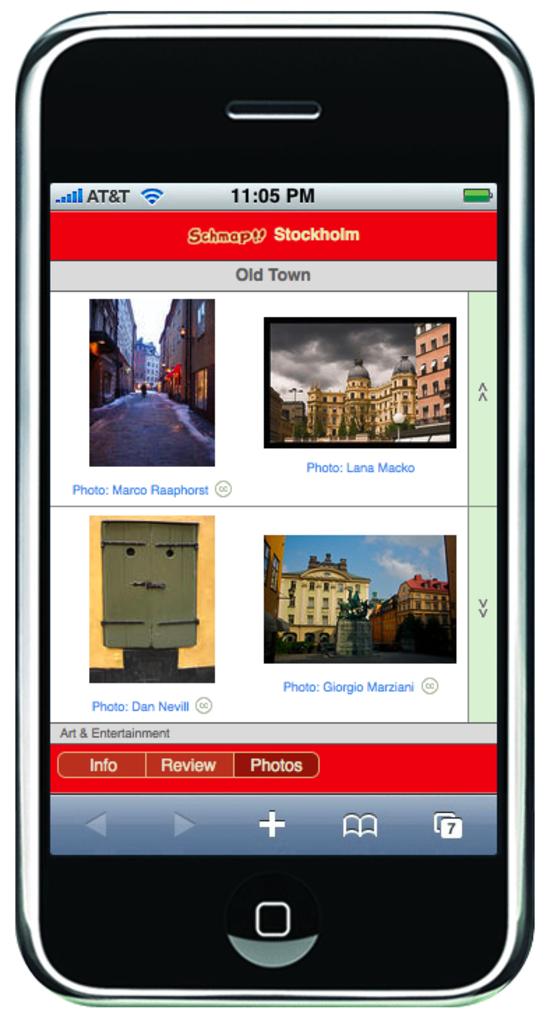What time does the phone say it is?
Make the answer very short. 11:05 pm. Which tab is highlighted on the bottom?
Give a very brief answer. Photos. 